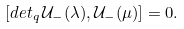<formula> <loc_0><loc_0><loc_500><loc_500>[ d e t _ { q } \, \mathcal { U } _ { - } ( \lambda ) , \mathcal { U } _ { - } ( \mu ) ] = 0 .</formula> 